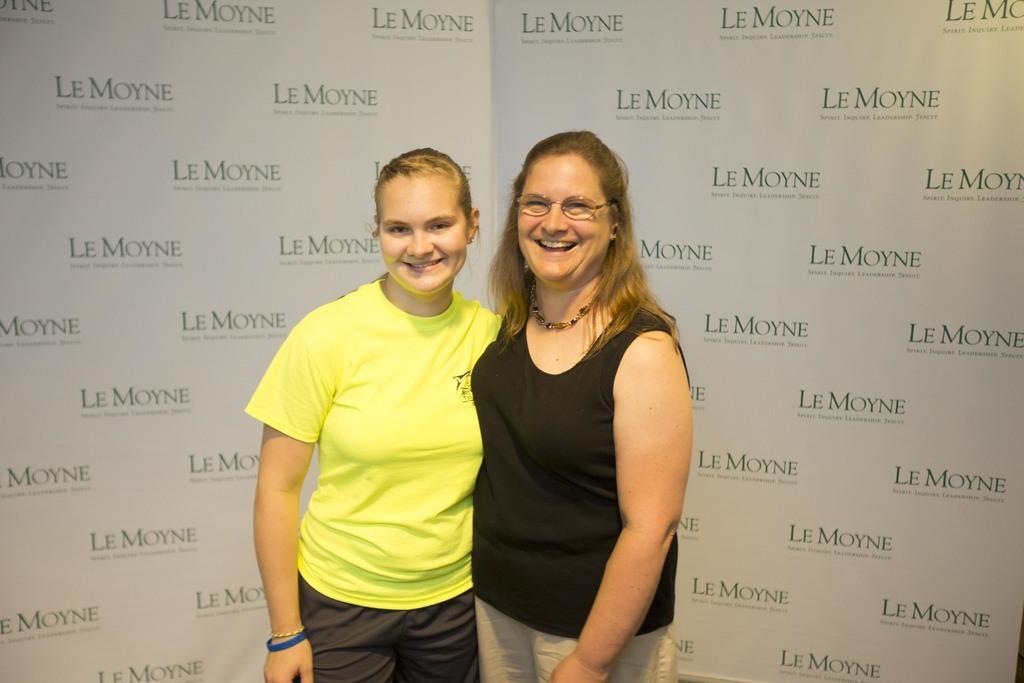How would you summarize this image in a sentence or two? In the image there are two women standing in the foreground and behind them there are some names of the sponsors. 